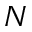<formula> <loc_0><loc_0><loc_500><loc_500>N</formula> 